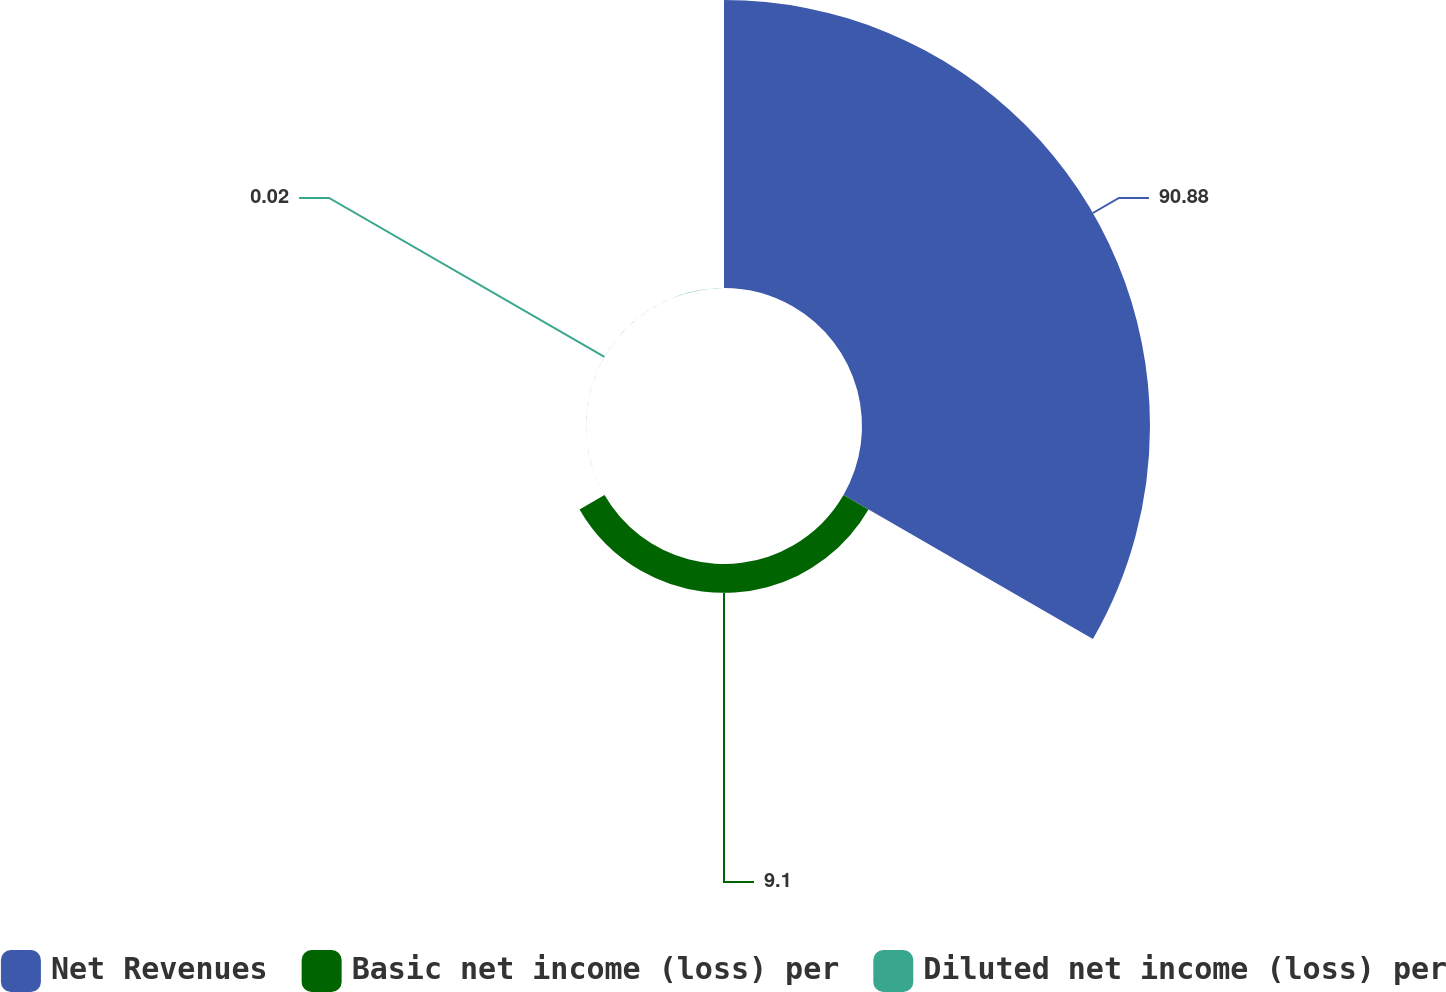Convert chart. <chart><loc_0><loc_0><loc_500><loc_500><pie_chart><fcel>Net Revenues<fcel>Basic net income (loss) per<fcel>Diluted net income (loss) per<nl><fcel>90.88%<fcel>9.1%<fcel>0.02%<nl></chart> 